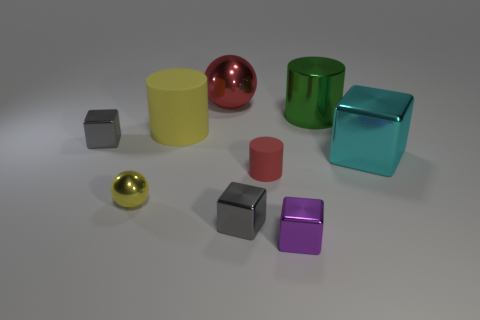How many objects are there, and can you categorize them by color? There are nine objects in the image. Categorizing them by color, we have one yellow cylinder, one red sphere, one green cube, one cyan cube, two grey cubes, one gold sphere, one pink cylinder, and one purple cube. They present a variety of hues and provide a rich palette that gives the image a vibrant yet harmonious composition. 